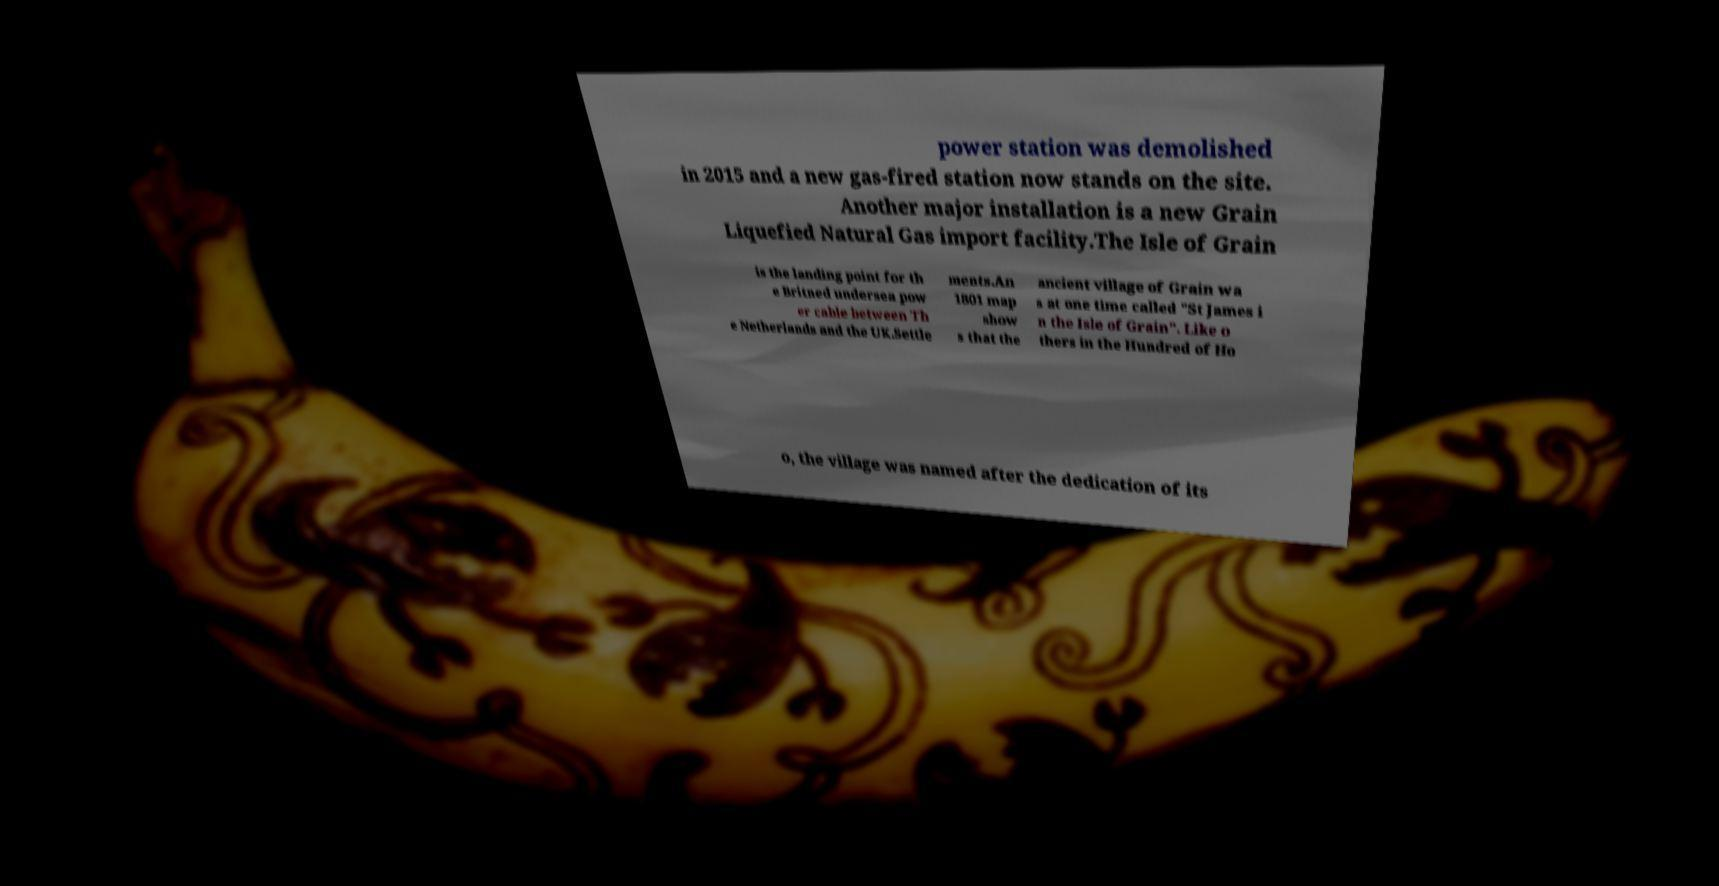For documentation purposes, I need the text within this image transcribed. Could you provide that? power station was demolished in 2015 and a new gas-fired station now stands on the site. Another major installation is a new Grain Liquefied Natural Gas import facility.The Isle of Grain is the landing point for th e Britned undersea pow er cable between Th e Netherlands and the UK.Settle ments.An 1801 map show s that the ancient village of Grain wa s at one time called "St James i n the Isle of Grain". Like o thers in the Hundred of Ho o, the village was named after the dedication of its 